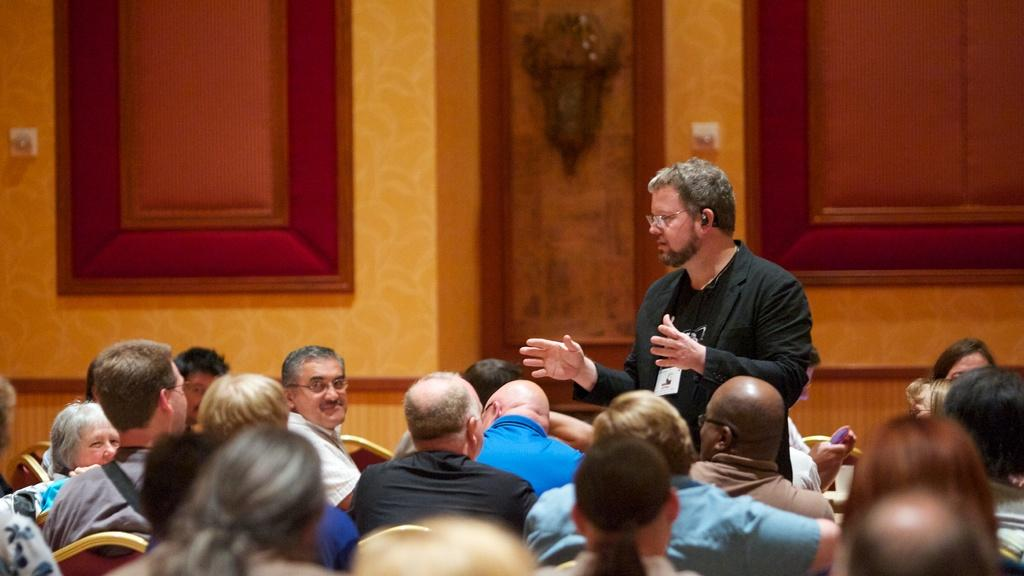Who is the main subject in the image? There is a man in the image. What is the man wearing? The man is wearing a black coat. What is the man doing in the image? The man is explaining something to an audience. How is the audience positioned in the image? The audience is sitting on chairs. What can be seen in the background of the image? There is a wooden crafted wall in the background. What color is the cushion on the wooden wall? The wooden wall has a red color cushion. Where is the monkey sitting in the image? There is no monkey present in the image. What type of frame surrounds the image? The image does not show a frame; it is a photograph or digital image. 